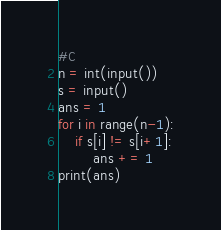Convert code to text. <code><loc_0><loc_0><loc_500><loc_500><_Python_>#C
n = int(input())
s = input()
ans = 1
for i in range(n-1):
    if s[i] != s[i+1]:
        ans += 1
print(ans)</code> 